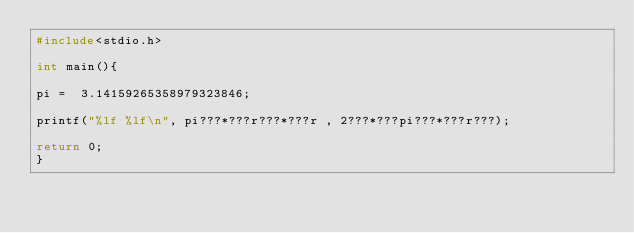<code> <loc_0><loc_0><loc_500><loc_500><_C++_>#include<stdio.h>

int main(){

pi =  3.14159265358979323846;

printf("%lf %lf\n", pi???*???r???*???r , 2???*???pi???*???r???);

return 0;
}</code> 